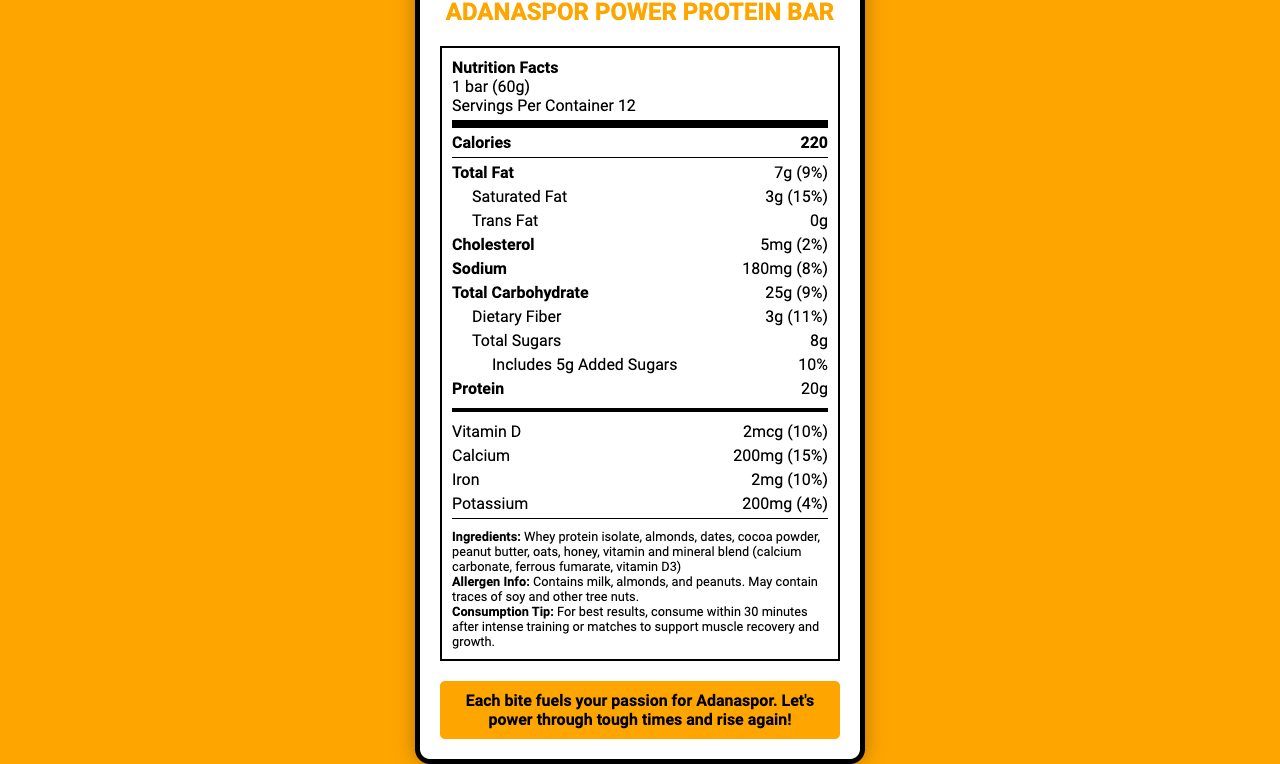what is the serving size of the Adanaspor Power Protein Bar? The serving size is explicitly mentioned as "1 bar (60g)" in the Nutrition Facts label.
Answer: 1 bar (60g) how many servings are there per container? The document states that there are 12 servings per container.
Answer: 12 how many calories are in one serving of the Adanaspor Power Protein Bar? The number of calories per serving is listed as "220" on the label.
Answer: 220 how much total fat does one protein bar contain? The total fat amount is specified as "7g" in the Nutrition Facts section.
Answer: 7g what is the amount of dietary fiber per serving? The dietary fiber content is listed as "3g" on the label.
Answer: 3g what percentage of the daily value of protein does one bar provide? The daily value percentage for protein is given as "40%" in the Nutrition Facts.
Answer: 40% how much saturated fat does the bar have in one serving? A. 1g B. 2g C. 3g D. 4g The amount of saturated fat listed is "3g," which corresponds to option C.
Answer: C. 3g what is the main idea of the document? This summary captures the main elements of the document, including nutritional information, ingredients, and the product's connection to Adanaspor.
Answer: The document is a nutrition facts label for the Adanaspor Power Protein Bar, detailing its nutritional content, ingredients, allergen information, and special features tailored for athletes, while also highlighting its connection to the Adanaspor team. is there any trans fat in the Adanaspor Power Protein Bar? The document indicates that there is "0g" of trans fat.
Answer: No what are the primary and secondary colors used in the branding of the protein bar? The document mentions that the primary color is "Orange" and the secondary color is "Black."
Answer: Orange and Black who manufactures the Adanaspor Power Protein Bar? The manufacturer is listed as "Adana Sports Nutrition Ltd." on the document.
Answer: Adana Sports Nutrition Ltd. how much calcium is in one protein bar serving? The calcium content per serving is specified as "200mg" in the Nutrition Facts.
Answer: 200mg does the bar contain any artificial sweeteners or preservatives? The document states that there are "No artificial sweeteners or preservatives."
Answer: No when should the bar be consumed for best results? A. Before training B. During training C. Within 30 minutes after training D. At bedtime The consumption tip advises consuming the bar within 30 minutes after intense training to support muscle recovery and growth.
Answer: C. Within 30 minutes after training does the document provide information on where to buy the protein bar? The document does not mention specific information on where to purchase the protein bar.
Answer: Not enough information 